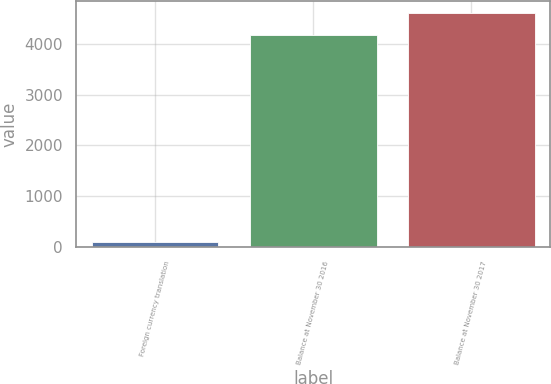<chart> <loc_0><loc_0><loc_500><loc_500><bar_chart><fcel>Foreign currency translation<fcel>Balance at November 30 2016<fcel>Balance at November 30 2017<nl><fcel>95.5<fcel>4185.5<fcel>4609.5<nl></chart> 